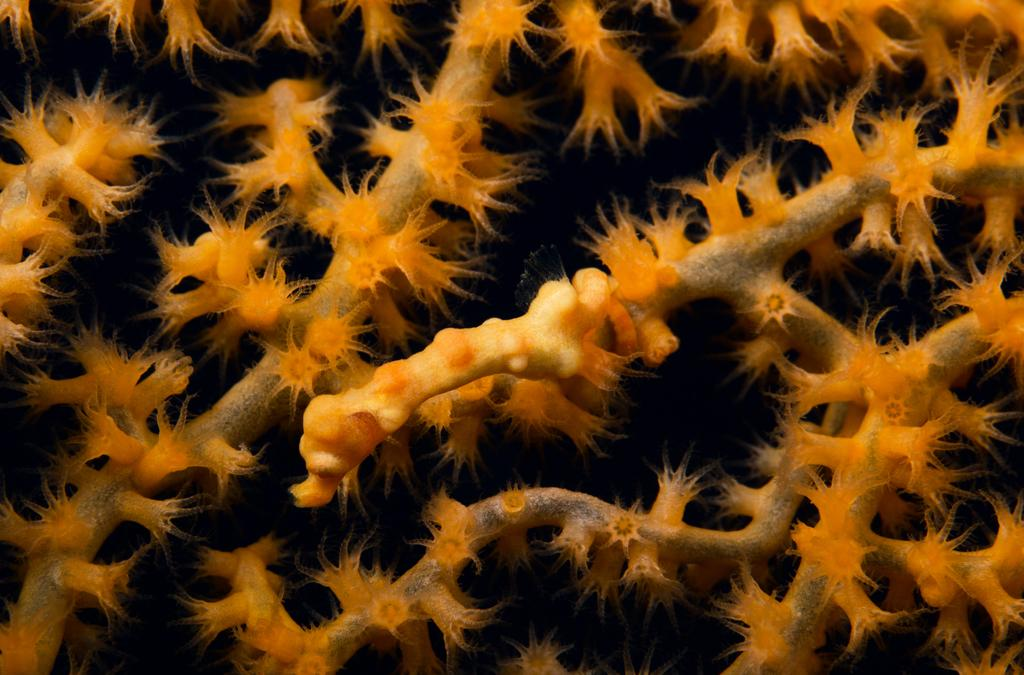What type of plants can be seen in the image? There are underwater plants in the image. Can you describe the environment in which the plants are located? The plants are located underwater. What might be the purpose of these underwater plants? Underwater plants can provide habitats for marine life and contribute to the overall health of the ecosystem. What type of kick is being performed by the secretary in the image? There is no secretary or kick present in the image; it features underwater plants. 